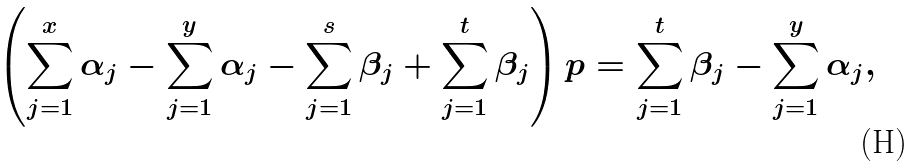<formula> <loc_0><loc_0><loc_500><loc_500>\left ( \sum _ { j = 1 } ^ { x } \alpha _ { j } - \sum _ { j = 1 } ^ { y } \alpha _ { j } - \sum _ { j = 1 } ^ { s } \beta _ { j } + \sum _ { j = 1 } ^ { t } \beta _ { j } \right ) p = \sum _ { j = 1 } ^ { t } \beta _ { j } - \sum _ { j = 1 } ^ { y } \alpha _ { j } ,</formula> 